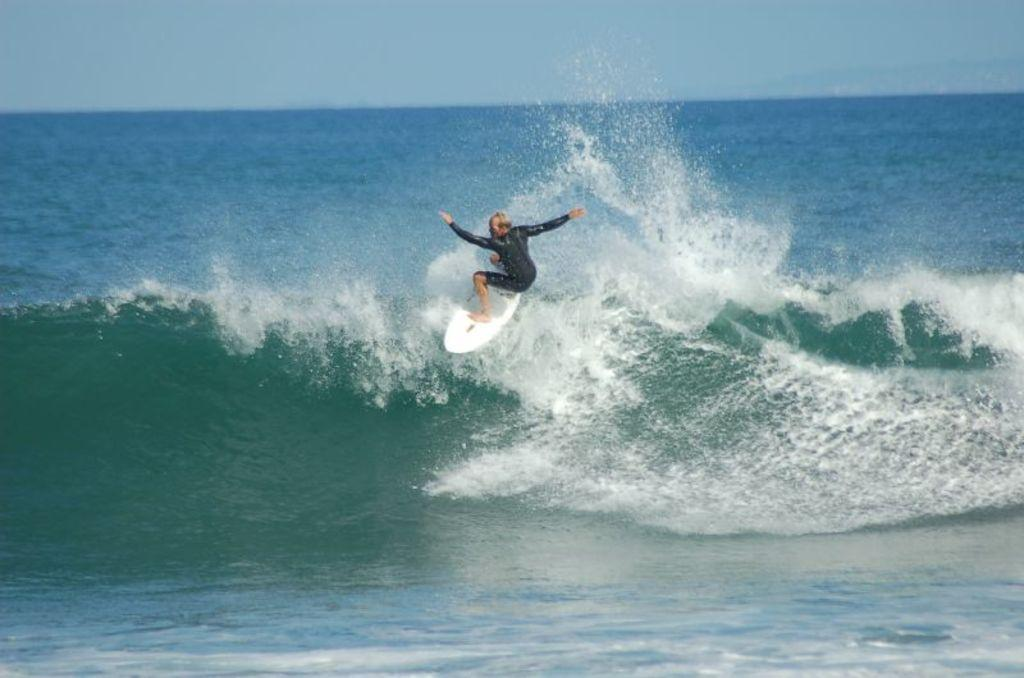Who is the person in the image? There is a man in the image. What is the man doing in the image? The man is surfing on a wave. What is the natural environment in the image? There is water visible in the background of the image. What is visible at the top of the image? The sky is visible at the top of the image. What type of suit is the man wearing while surfing in the image? There is no suit visible in the image; the man is wearing surfing attire. 